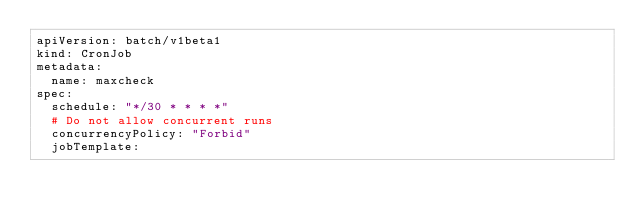Convert code to text. <code><loc_0><loc_0><loc_500><loc_500><_YAML_>apiVersion: batch/v1beta1
kind: CronJob
metadata:
  name: maxcheck
spec:
  schedule: "*/30 * * * *"
  # Do not allow concurrent runs
  concurrencyPolicy: "Forbid"
  jobTemplate:</code> 